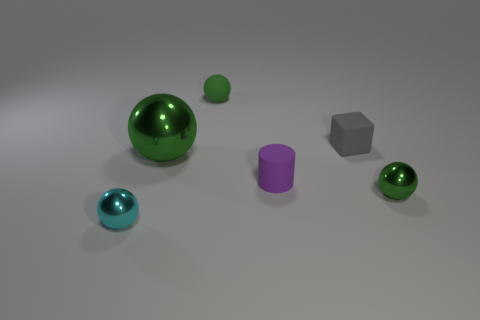Subtract 1 balls. How many balls are left? 3 Subtract all gray blocks. How many green balls are left? 3 Subtract all cyan spheres. How many spheres are left? 3 Subtract all cyan metallic balls. How many balls are left? 3 Subtract all red balls. Subtract all blue blocks. How many balls are left? 4 Add 2 small spheres. How many objects exist? 8 Subtract all cylinders. How many objects are left? 5 Subtract all big shiny objects. Subtract all large balls. How many objects are left? 4 Add 4 green shiny balls. How many green shiny balls are left? 6 Add 2 tiny cylinders. How many tiny cylinders exist? 3 